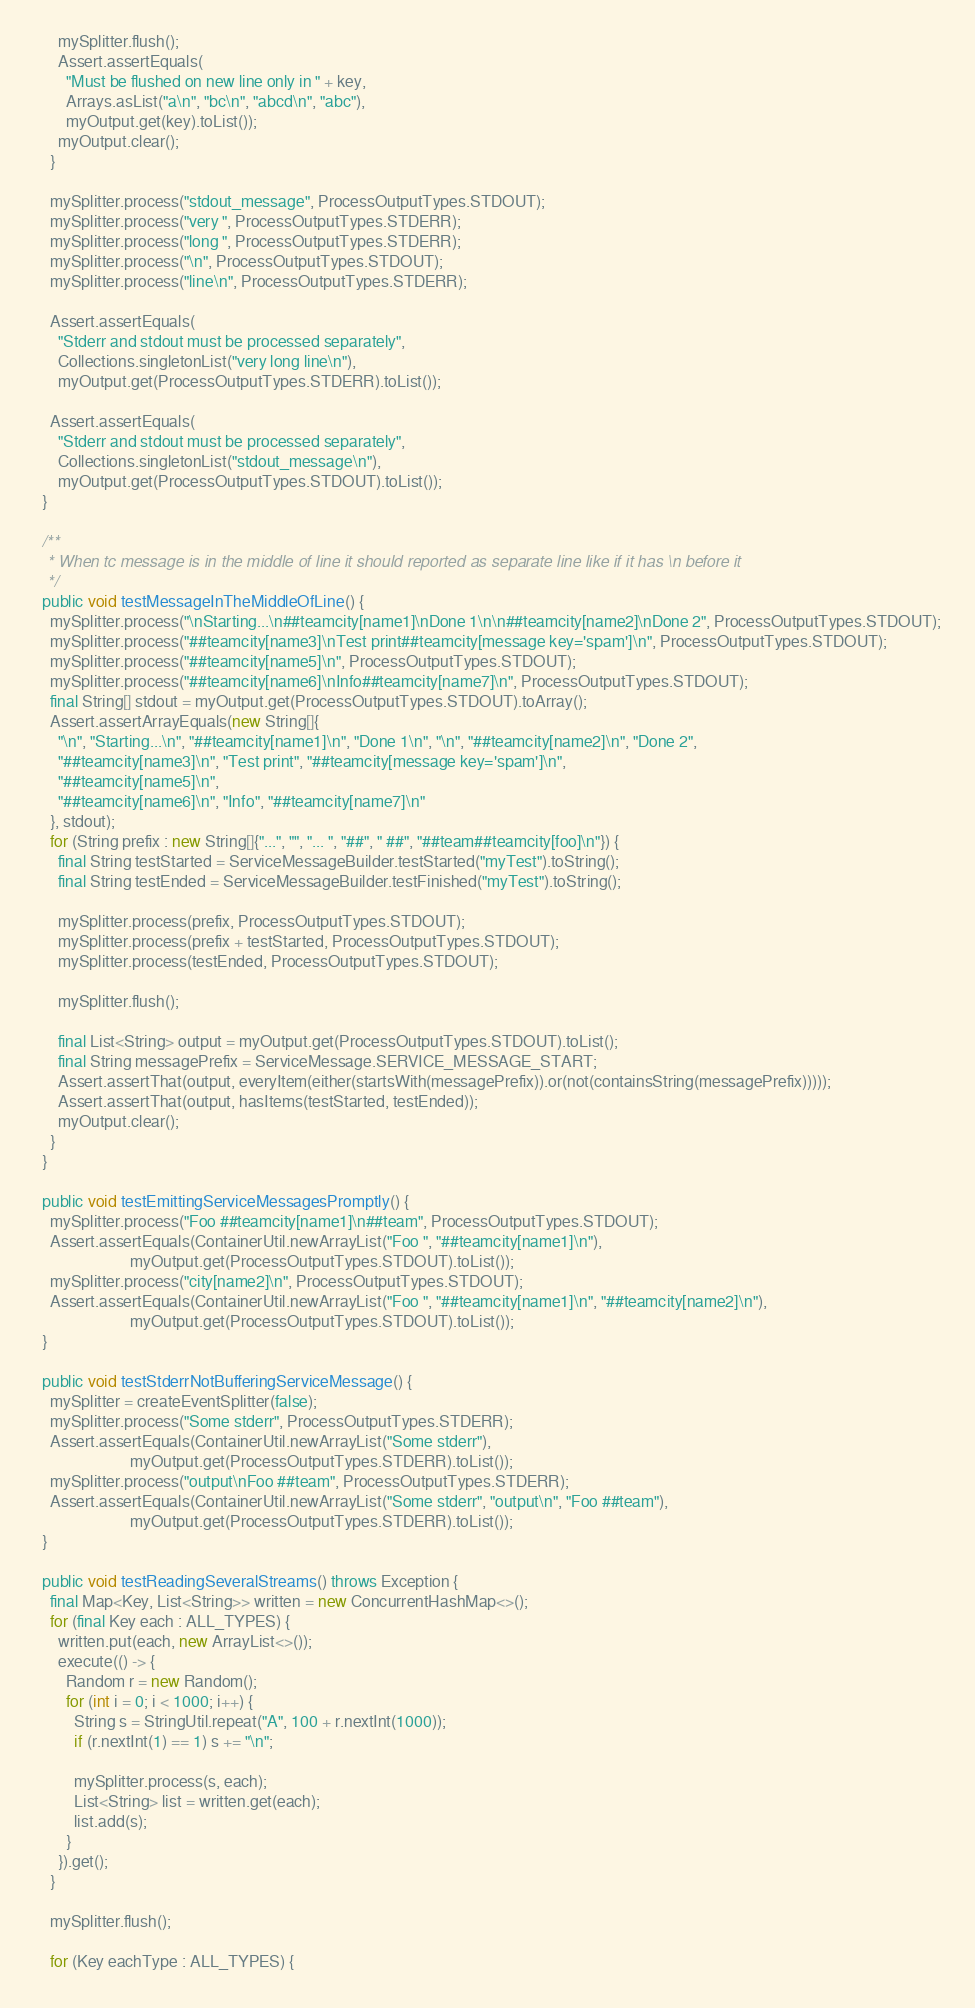Convert code to text. <code><loc_0><loc_0><loc_500><loc_500><_Java_>      mySplitter.flush();
      Assert.assertEquals(
        "Must be flushed on new line only in " + key,
        Arrays.asList("a\n", "bc\n", "abcd\n", "abc"),
        myOutput.get(key).toList());
      myOutput.clear();
    }

    mySplitter.process("stdout_message", ProcessOutputTypes.STDOUT);
    mySplitter.process("very ", ProcessOutputTypes.STDERR);
    mySplitter.process("long ", ProcessOutputTypes.STDERR);
    mySplitter.process("\n", ProcessOutputTypes.STDOUT);
    mySplitter.process("line\n", ProcessOutputTypes.STDERR);

    Assert.assertEquals(
      "Stderr and stdout must be processed separately",
      Collections.singletonList("very long line\n"),
      myOutput.get(ProcessOutputTypes.STDERR).toList());

    Assert.assertEquals(
      "Stderr and stdout must be processed separately",
      Collections.singletonList("stdout_message\n"),
      myOutput.get(ProcessOutputTypes.STDOUT).toList());
  }

  /**
   * When tc message is in the middle of line it should reported as separate line like if it has \n before it
   */
  public void testMessageInTheMiddleOfLine() {
    mySplitter.process("\nStarting...\n##teamcity[name1]\nDone 1\n\n##teamcity[name2]\nDone 2", ProcessOutputTypes.STDOUT);
    mySplitter.process("##teamcity[name3]\nTest print##teamcity[message key='spam']\n", ProcessOutputTypes.STDOUT);
    mySplitter.process("##teamcity[name5]\n", ProcessOutputTypes.STDOUT);
    mySplitter.process("##teamcity[name6]\nInfo##teamcity[name7]\n", ProcessOutputTypes.STDOUT);
    final String[] stdout = myOutput.get(ProcessOutputTypes.STDOUT).toArray();
    Assert.assertArrayEquals(new String[]{
      "\n", "Starting...\n", "##teamcity[name1]\n", "Done 1\n", "\n", "##teamcity[name2]\n", "Done 2",
      "##teamcity[name3]\n", "Test print", "##teamcity[message key='spam']\n",
      "##teamcity[name5]\n",
      "##teamcity[name6]\n", "Info", "##teamcity[name7]\n"
    }, stdout);
    for (String prefix : new String[]{"...", "", "... ", "##", " ##", "##team##teamcity[foo]\n"}) {
      final String testStarted = ServiceMessageBuilder.testStarted("myTest").toString();
      final String testEnded = ServiceMessageBuilder.testFinished("myTest").toString();

      mySplitter.process(prefix, ProcessOutputTypes.STDOUT);
      mySplitter.process(prefix + testStarted, ProcessOutputTypes.STDOUT);
      mySplitter.process(testEnded, ProcessOutputTypes.STDOUT);

      mySplitter.flush();

      final List<String> output = myOutput.get(ProcessOutputTypes.STDOUT).toList();
      final String messagePrefix = ServiceMessage.SERVICE_MESSAGE_START;
      Assert.assertThat(output, everyItem(either(startsWith(messagePrefix)).or(not(containsString(messagePrefix)))));
      Assert.assertThat(output, hasItems(testStarted, testEnded));
      myOutput.clear();
    }
  }

  public void testEmittingServiceMessagesPromptly() {
    mySplitter.process("Foo ##teamcity[name1]\n##team", ProcessOutputTypes.STDOUT);
    Assert.assertEquals(ContainerUtil.newArrayList("Foo ", "##teamcity[name1]\n"),
                        myOutput.get(ProcessOutputTypes.STDOUT).toList());
    mySplitter.process("city[name2]\n", ProcessOutputTypes.STDOUT);
    Assert.assertEquals(ContainerUtil.newArrayList("Foo ", "##teamcity[name1]\n", "##teamcity[name2]\n"),
                        myOutput.get(ProcessOutputTypes.STDOUT).toList());
  }

  public void testStderrNotBufferingServiceMessage() {
    mySplitter = createEventSplitter(false);
    mySplitter.process("Some stderr", ProcessOutputTypes.STDERR);
    Assert.assertEquals(ContainerUtil.newArrayList("Some stderr"),
                        myOutput.get(ProcessOutputTypes.STDERR).toList());
    mySplitter.process("output\nFoo ##team", ProcessOutputTypes.STDERR);
    Assert.assertEquals(ContainerUtil.newArrayList("Some stderr", "output\n", "Foo ##team"),
                        myOutput.get(ProcessOutputTypes.STDERR).toList());
  }

  public void testReadingSeveralStreams() throws Exception {
    final Map<Key, List<String>> written = new ConcurrentHashMap<>();
    for (final Key each : ALL_TYPES) {
      written.put(each, new ArrayList<>());
      execute(() -> {
        Random r = new Random();
        for (int i = 0; i < 1000; i++) {
          String s = StringUtil.repeat("A", 100 + r.nextInt(1000));
          if (r.nextInt(1) == 1) s += "\n";

          mySplitter.process(s, each);
          List<String> list = written.get(each);
          list.add(s);
        }
      }).get();
    }

    mySplitter.flush();

    for (Key eachType : ALL_TYPES) {</code> 